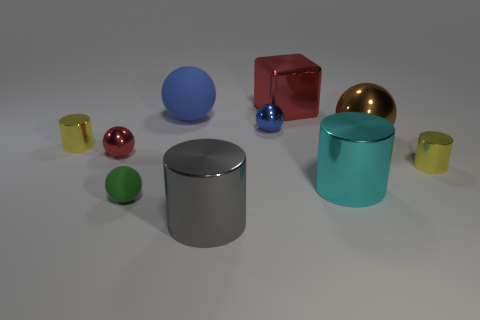What number of yellow things are the same shape as the gray thing?
Your answer should be very brief. 2. What is the material of the large blue ball?
Offer a very short reply. Rubber. Is the number of big things to the left of the gray object the same as the number of big gray cylinders?
Ensure brevity in your answer.  Yes. What is the shape of the brown metal thing that is the same size as the cyan object?
Your answer should be very brief. Sphere. There is a small yellow cylinder that is on the left side of the brown metallic ball; is there a small yellow cylinder that is to the left of it?
Offer a terse response. No. How many tiny things are either cyan metallic things or gray cylinders?
Give a very brief answer. 0. Is there a blue matte object that has the same size as the gray metal object?
Your answer should be compact. Yes. What number of matte objects are either red balls or large cylinders?
Your response must be concise. 0. There is a small thing that is the same color as the large cube; what shape is it?
Provide a short and direct response. Sphere. How many big red things are there?
Your answer should be compact. 1. 